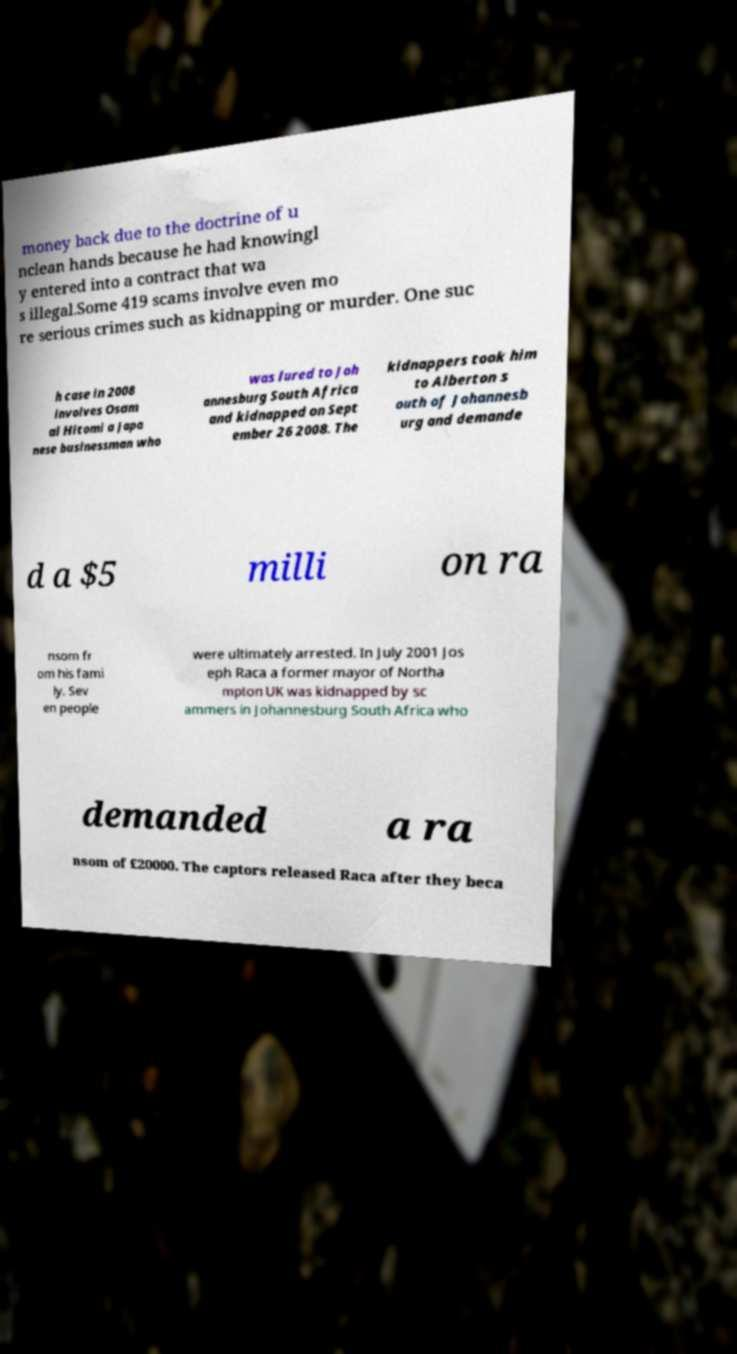For documentation purposes, I need the text within this image transcribed. Could you provide that? money back due to the doctrine of u nclean hands because he had knowingl y entered into a contract that wa s illegal.Some 419 scams involve even mo re serious crimes such as kidnapping or murder. One suc h case in 2008 involves Osam ai Hitomi a Japa nese businessman who was lured to Joh annesburg South Africa and kidnapped on Sept ember 26 2008. The kidnappers took him to Alberton s outh of Johannesb urg and demande d a $5 milli on ra nsom fr om his fami ly. Sev en people were ultimately arrested. In July 2001 Jos eph Raca a former mayor of Northa mpton UK was kidnapped by sc ammers in Johannesburg South Africa who demanded a ra nsom of £20000. The captors released Raca after they beca 